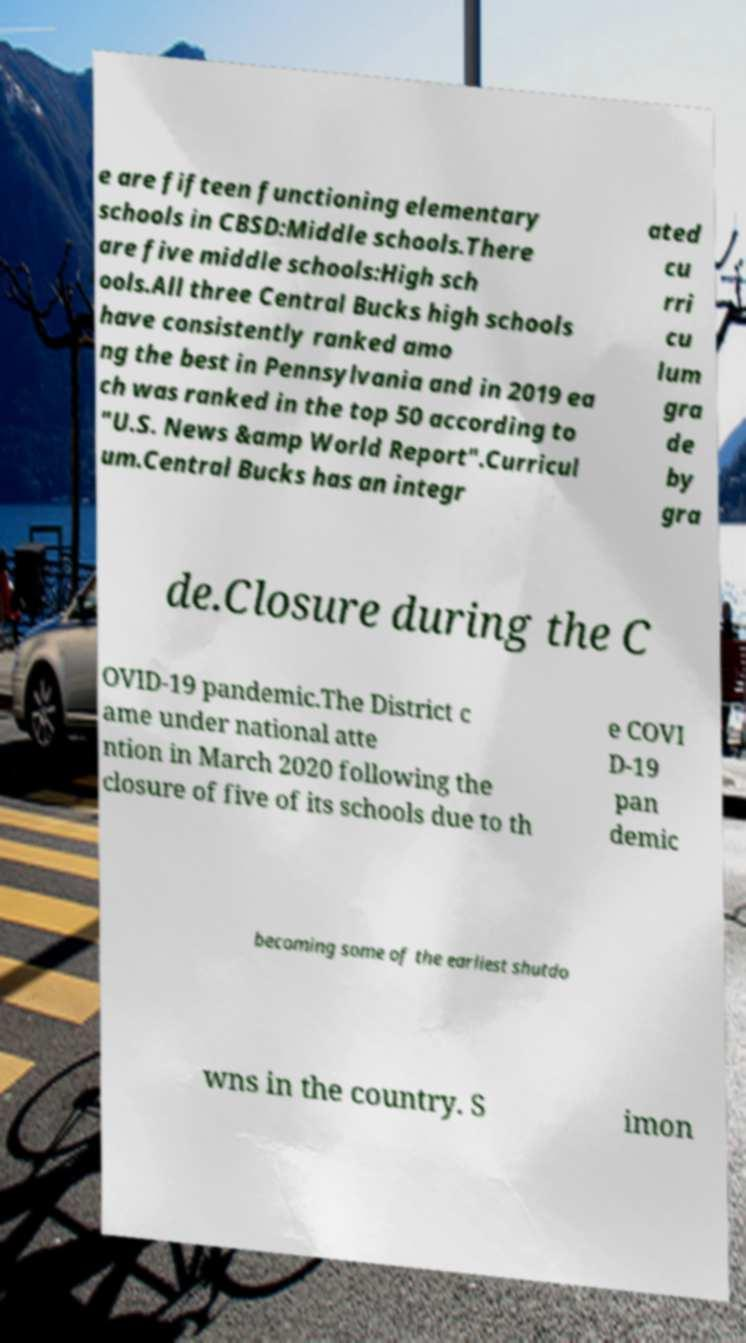Could you extract and type out the text from this image? e are fifteen functioning elementary schools in CBSD:Middle schools.There are five middle schools:High sch ools.All three Central Bucks high schools have consistently ranked amo ng the best in Pennsylvania and in 2019 ea ch was ranked in the top 50 according to "U.S. News &amp World Report".Curricul um.Central Bucks has an integr ated cu rri cu lum gra de by gra de.Closure during the C OVID-19 pandemic.The District c ame under national atte ntion in March 2020 following the closure of five of its schools due to th e COVI D-19 pan demic becoming some of the earliest shutdo wns in the country. S imon 